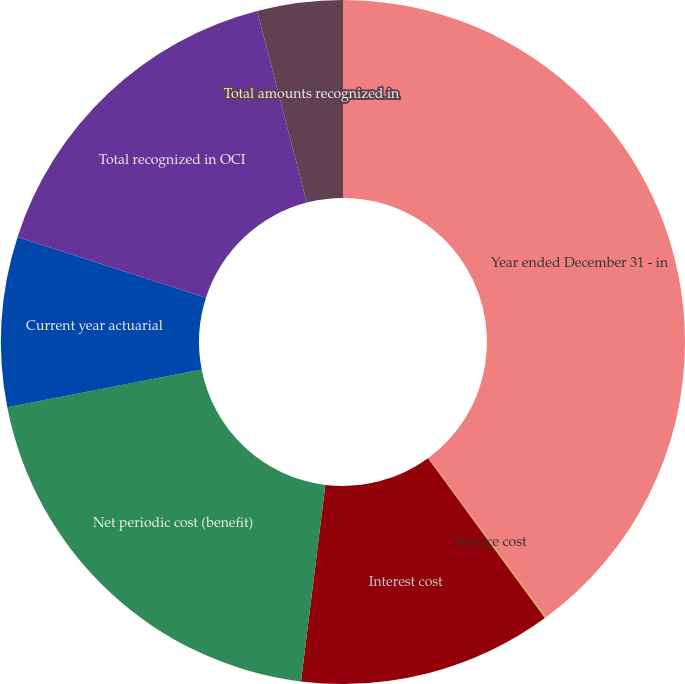Convert chart to OTSL. <chart><loc_0><loc_0><loc_500><loc_500><pie_chart><fcel>Year ended December 31 - in<fcel>Service cost<fcel>Interest cost<fcel>Net periodic cost (benefit)<fcel>Current year actuarial<fcel>Total recognized in OCI<fcel>Total amounts recognized in<nl><fcel>39.89%<fcel>0.06%<fcel>12.01%<fcel>19.98%<fcel>8.03%<fcel>15.99%<fcel>4.04%<nl></chart> 